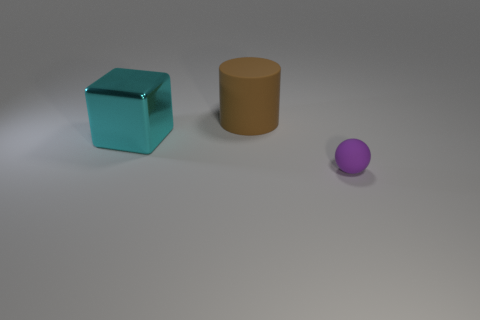Are there any other things that are the same size as the matte ball?
Your answer should be very brief. No. Is there a shiny cube that is on the left side of the rubber object that is left of the tiny ball?
Keep it short and to the point. Yes. Are there fewer purple rubber spheres than big purple shiny balls?
Your answer should be very brief. No. How many gray things are either large things or matte balls?
Provide a short and direct response. 0. What is the size of the rubber object behind the matte thing that is in front of the big cyan metal block?
Make the answer very short. Large. What number of metal objects are the same size as the matte cylinder?
Offer a terse response. 1. Do the purple sphere and the cube have the same size?
Offer a terse response. No. There is a thing that is both on the right side of the large metallic object and in front of the brown rubber object; what is its size?
Provide a short and direct response. Small. Is the number of large brown cylinders on the right side of the brown rubber cylinder greater than the number of big shiny things that are in front of the small purple object?
Give a very brief answer. No. There is a thing that is in front of the cyan block; is its color the same as the large matte thing?
Make the answer very short. No. 